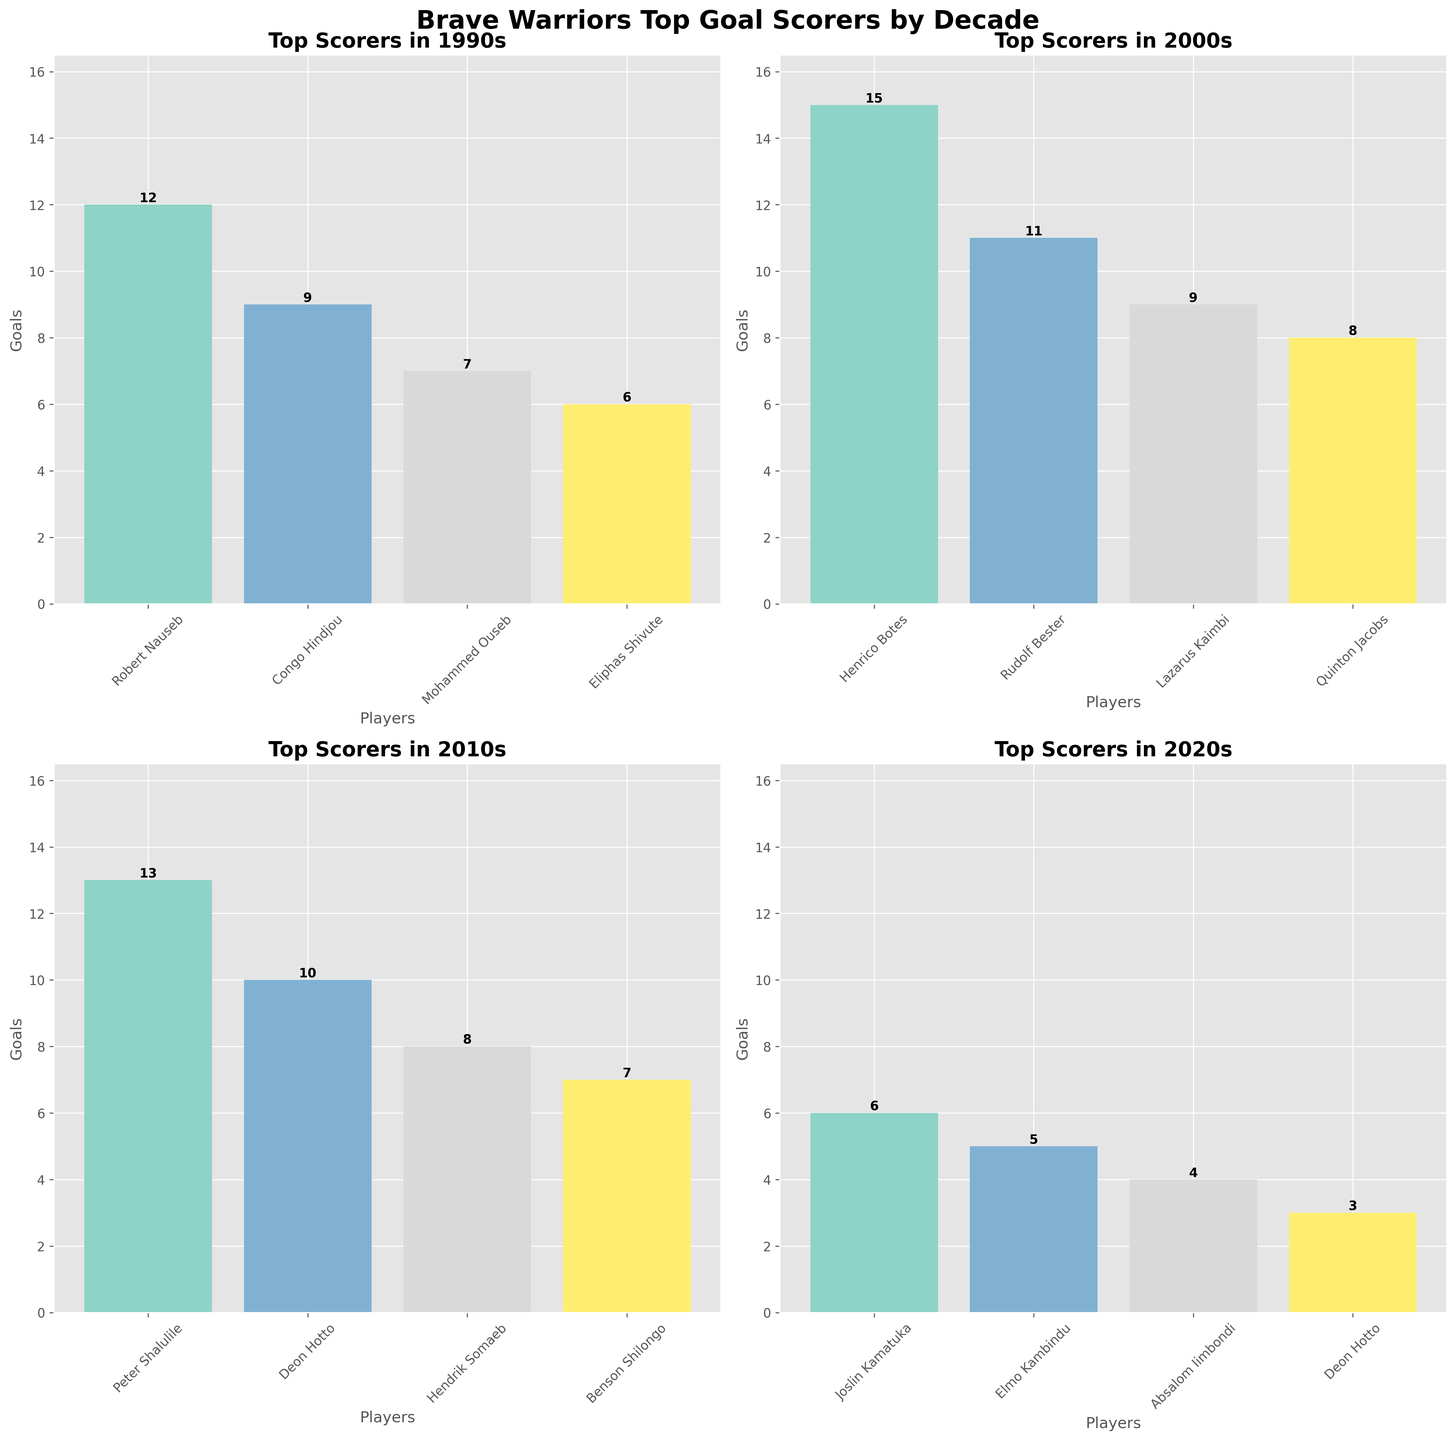Which player scored the highest number of goals in the 1990s? The tallest bar in the plot for the 1990s represents Robert Nauseb with 12 goals.
Answer: Robert Nauseb Who are the top four goal scorers in the 2000s? The four tallest bars in the plot for the 2000s are for Henrico Botes, Rudolf Bester, Lazarus Kaimbi, and Quinton Jacobs.
Answer: Henrico Botes, Rudolf Bester, Lazarus Kaimbi, Quinton Jacobs How many total goals were scored by the top four players in the 2010s? Adding the goals of the top four players in the 2010s: Peter Shalulile (13), Deon Hotto (10), Hendrik Somaeb (8), and Benson Shilongo (7), the total is 13 + 10 + 8 + 7 = 38.
Answer: 38 Who scored more goals in the 2020s, Joslin Kamatuka or Elmo Kambindu? Comparing the bars for Joslin Kamatuka (6 goals) and Elmo Kambindu (5 goals), Joslin Kamatuka scored more.
Answer: Joslin Kamatuka What is the difference in goals between the top scorer of the 1990s and the top scorer of the 2000s? Robert Nauseb scored 12 goals in the 1990s, and Henrico Botes scored 15 goals in the 2000s. The difference is 15 - 12 = 3.
Answer: 3 Which player appears on the list for both the 2010s and the 2020s? Deon Hotto appears in both the 2010s and the 2020s lists of top goal scorers.
Answer: Deon Hotto How many goals did the fourth-highest scorer in the 1990s achieve? The fourth-highest scorer in the 1990s is Eliphas Shivute with 6 goals.
Answer: 6 What's the average number of goals scored by the top three players in the 2000s? Adding the goals of the top three players in the 2000s: Henrico Botes (15), Rudolf Bester (11), and Lazarus Kaimbi (9), the total is 15 + 11 + 9 = 35. The average is 35 / 3 = 11.67.
Answer: 11.67 